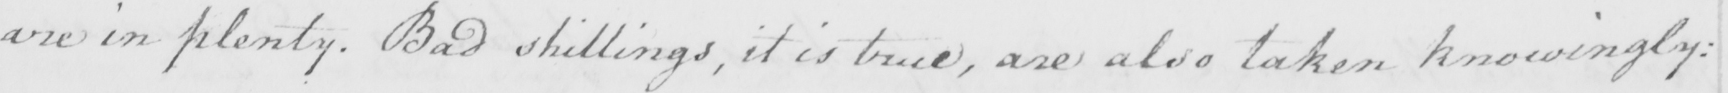Can you read and transcribe this handwriting? are in plenty . Bad shillings , it is true , are also taken knowingly : 